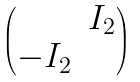Convert formula to latex. <formula><loc_0><loc_0><loc_500><loc_500>\begin{pmatrix} & I _ { 2 } \\ - I _ { 2 } & \\ \end{pmatrix}</formula> 